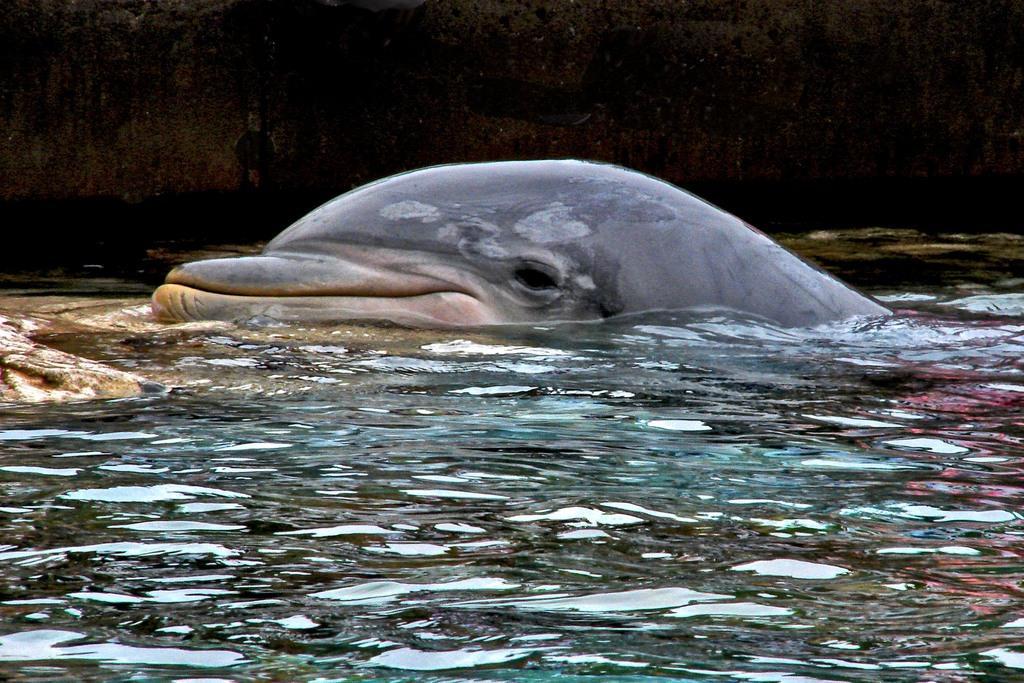Can you describe this image briefly? In this picture there is a dolphin in the center of the image in the water and there is water at the bottom side of the image. 